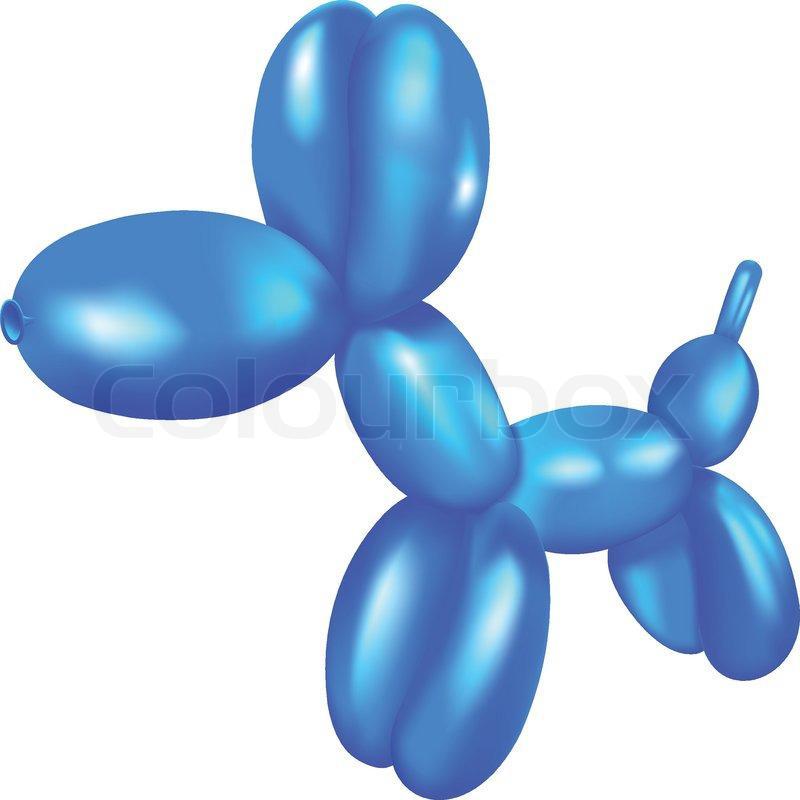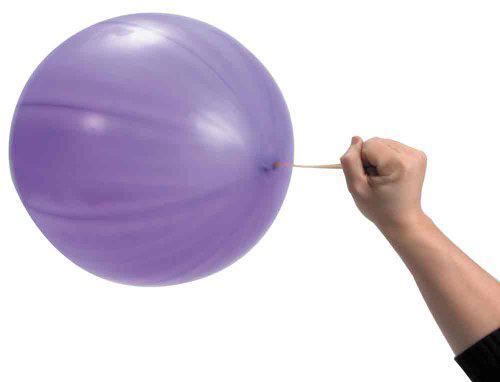The first image is the image on the left, the second image is the image on the right. Examine the images to the left and right. Is the description "At least one balloon has a string attached." accurate? Answer yes or no. Yes. 